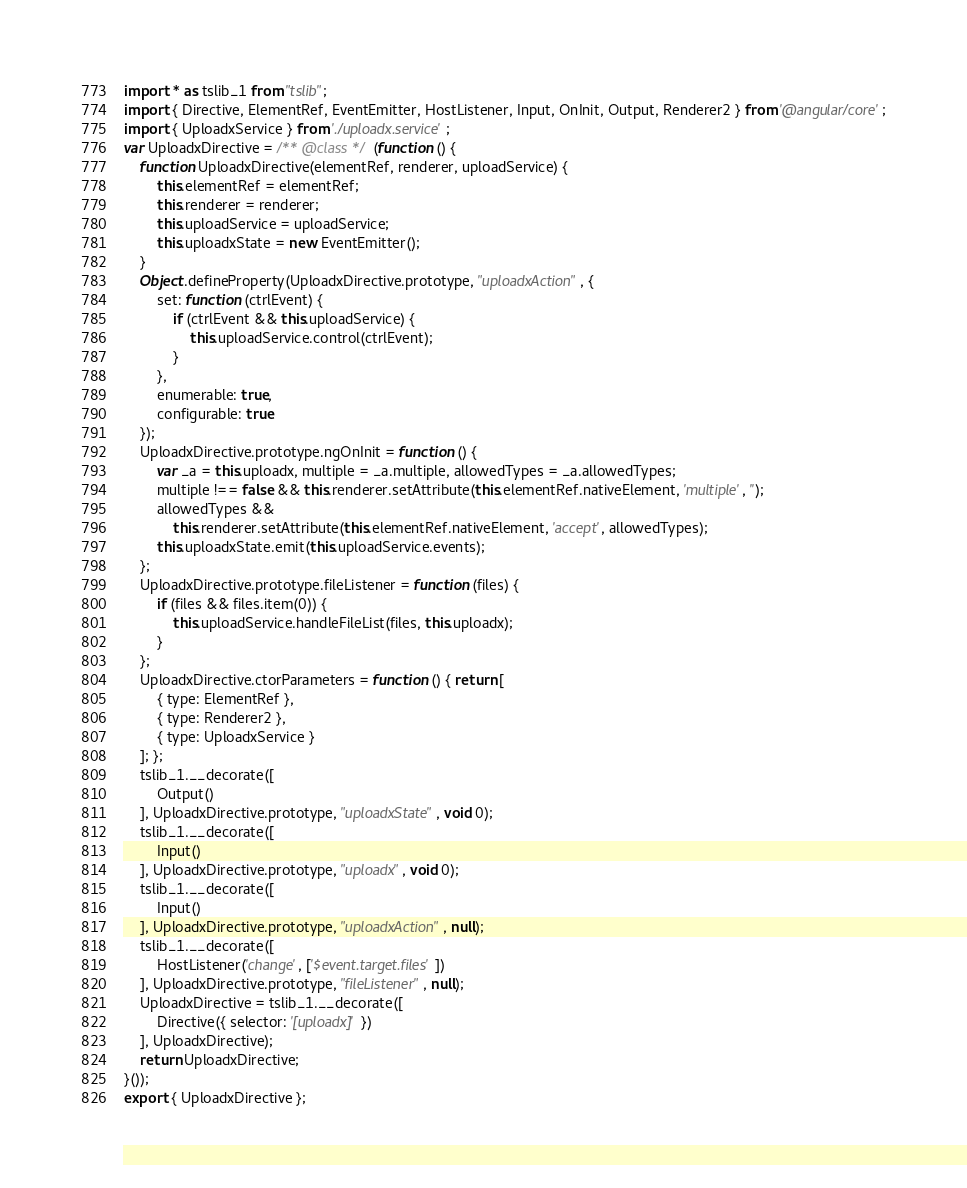Convert code to text. <code><loc_0><loc_0><loc_500><loc_500><_JavaScript_>import * as tslib_1 from "tslib";
import { Directive, ElementRef, EventEmitter, HostListener, Input, OnInit, Output, Renderer2 } from '@angular/core';
import { UploadxService } from './uploadx.service';
var UploadxDirective = /** @class */ (function () {
    function UploadxDirective(elementRef, renderer, uploadService) {
        this.elementRef = elementRef;
        this.renderer = renderer;
        this.uploadService = uploadService;
        this.uploadxState = new EventEmitter();
    }
    Object.defineProperty(UploadxDirective.prototype, "uploadxAction", {
        set: function (ctrlEvent) {
            if (ctrlEvent && this.uploadService) {
                this.uploadService.control(ctrlEvent);
            }
        },
        enumerable: true,
        configurable: true
    });
    UploadxDirective.prototype.ngOnInit = function () {
        var _a = this.uploadx, multiple = _a.multiple, allowedTypes = _a.allowedTypes;
        multiple !== false && this.renderer.setAttribute(this.elementRef.nativeElement, 'multiple', '');
        allowedTypes &&
            this.renderer.setAttribute(this.elementRef.nativeElement, 'accept', allowedTypes);
        this.uploadxState.emit(this.uploadService.events);
    };
    UploadxDirective.prototype.fileListener = function (files) {
        if (files && files.item(0)) {
            this.uploadService.handleFileList(files, this.uploadx);
        }
    };
    UploadxDirective.ctorParameters = function () { return [
        { type: ElementRef },
        { type: Renderer2 },
        { type: UploadxService }
    ]; };
    tslib_1.__decorate([
        Output()
    ], UploadxDirective.prototype, "uploadxState", void 0);
    tslib_1.__decorate([
        Input()
    ], UploadxDirective.prototype, "uploadx", void 0);
    tslib_1.__decorate([
        Input()
    ], UploadxDirective.prototype, "uploadxAction", null);
    tslib_1.__decorate([
        HostListener('change', ['$event.target.files'])
    ], UploadxDirective.prototype, "fileListener", null);
    UploadxDirective = tslib_1.__decorate([
        Directive({ selector: '[uploadx]' })
    ], UploadxDirective);
    return UploadxDirective;
}());
export { UploadxDirective };</code> 